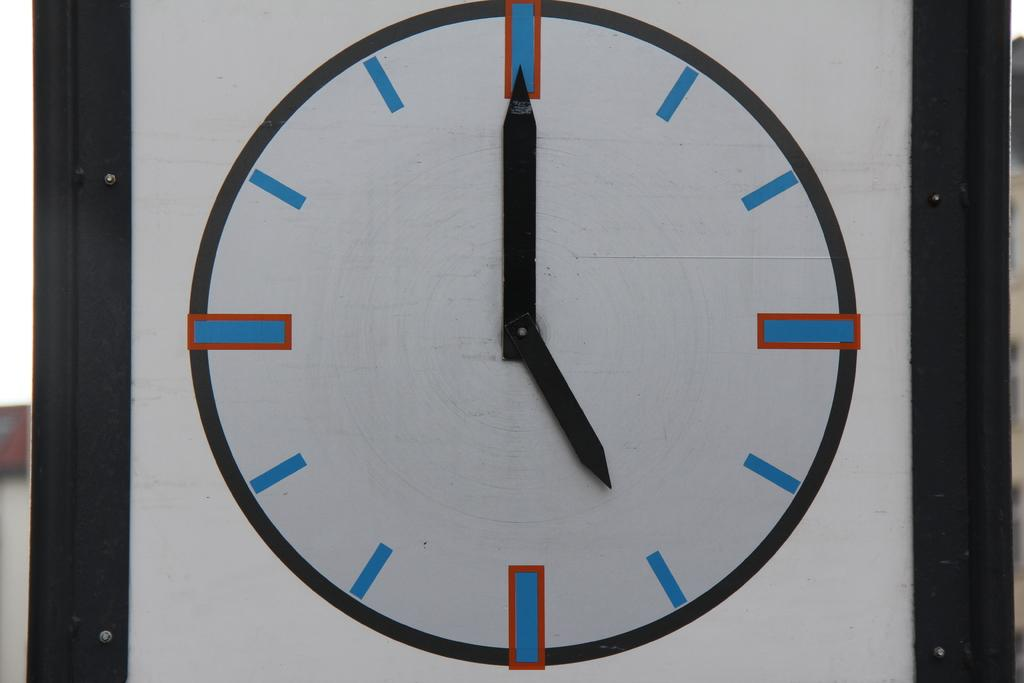What object in the image can be used to tell time? The wall clock in the image can be used to tell time. What colors are used to design the wall clock? The wall clock is in white, blue, and red colors. What type of ice can be seen melting on the wall clock in the image? There is no ice present in the image, and the wall clock is not melting. 